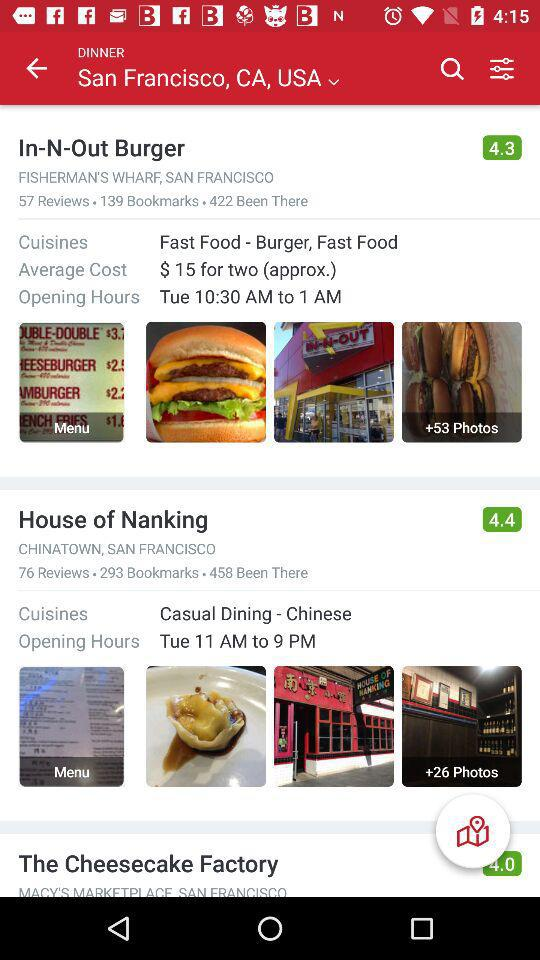What type of cuisine does "In-N-Out Burger" have? The type of cuisine that "In-N-Out Burger" has is "Fast Food". 